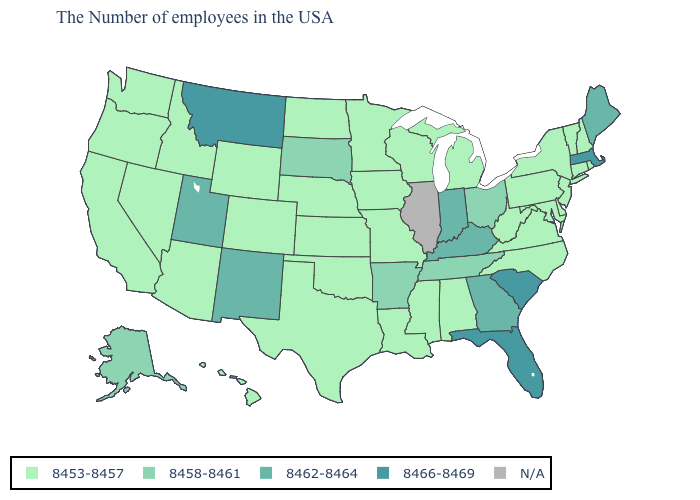What is the value of Minnesota?
Write a very short answer. 8453-8457. Which states hav the highest value in the MidWest?
Short answer required. Indiana. Among the states that border Texas , which have the lowest value?
Be succinct. Louisiana, Oklahoma. What is the value of Connecticut?
Give a very brief answer. 8453-8457. What is the value of Maryland?
Concise answer only. 8453-8457. Which states have the highest value in the USA?
Quick response, please. Massachusetts, South Carolina, Florida, Montana. Name the states that have a value in the range 8458-8461?
Keep it brief. Ohio, Tennessee, Arkansas, South Dakota, Alaska. What is the lowest value in the USA?
Give a very brief answer. 8453-8457. What is the value of Alabama?
Give a very brief answer. 8453-8457. Name the states that have a value in the range 8466-8469?
Short answer required. Massachusetts, South Carolina, Florida, Montana. What is the highest value in the USA?
Write a very short answer. 8466-8469. What is the lowest value in states that border Tennessee?
Be succinct. 8453-8457. Among the states that border North Dakota , which have the highest value?
Quick response, please. Montana. What is the lowest value in the USA?
Be succinct. 8453-8457. 